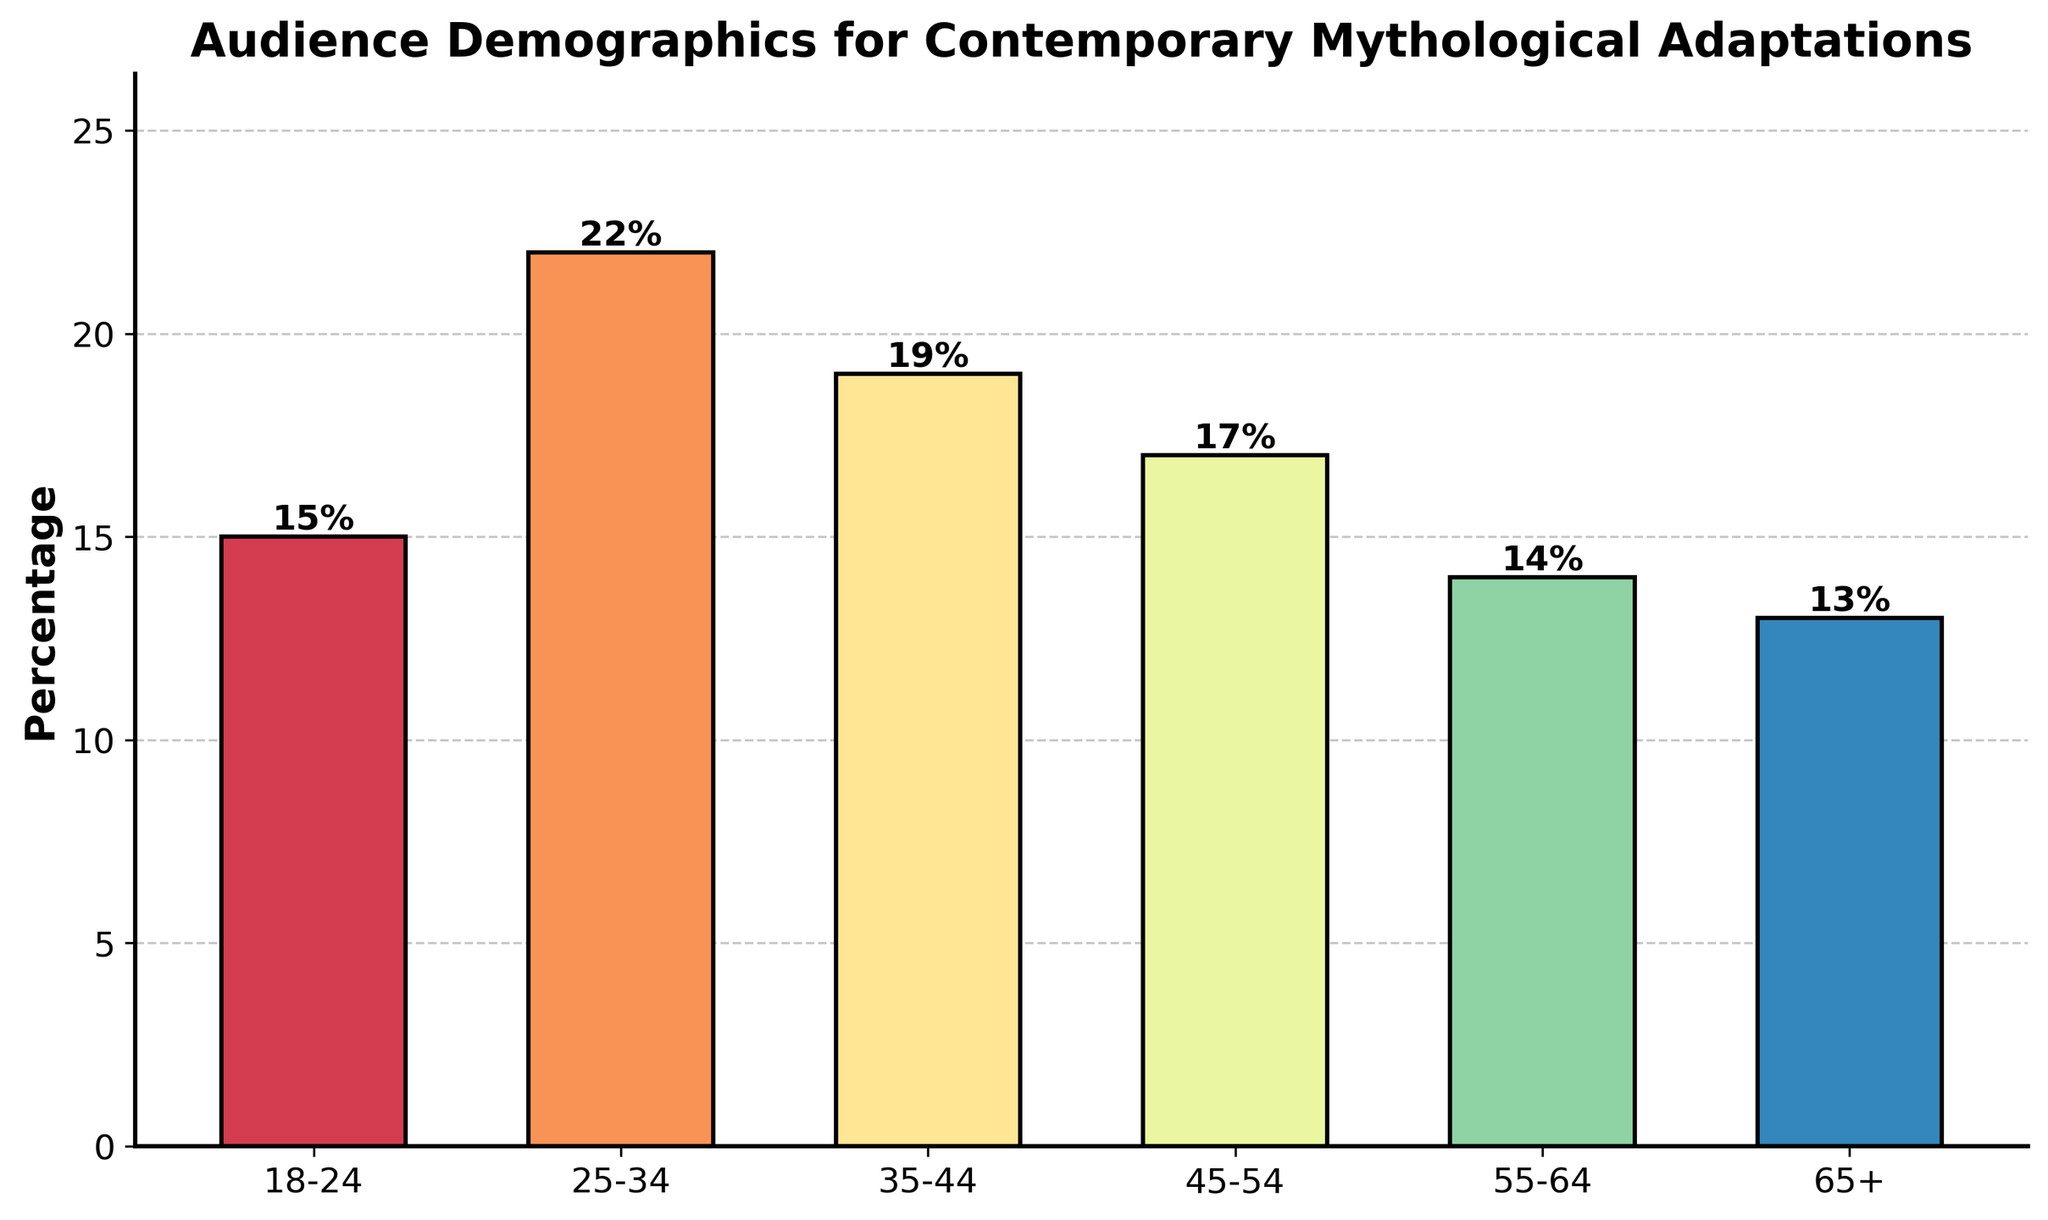What age group has the highest percentage of the audience? The tallest bar in the chart represents the age group with the highest percentage. The age group 25-34 has the highest bar at 22%.
Answer: 25-34 Which age group has the lowest percentage of the audience? The shortest bar in the chart represents the age group with the lowest percentage. The age group 65+ has the shortest bar at 13%.
Answer: 65+ What is the combined percentage of the audience for the 18-24 and 25-34 age groups? Add the percentages of the 18-24 and 25-34 age groups: 15% + 22% = 37%.
Answer: 37% Which age groups have a percentage of 17% or above? Identify the bars that reach or exceed the 17% mark. The age groups 25-34, 35-44, and 45-54 each have a percentage of 17% or higher.
Answer: 25-34, 35-44, 45-54 What is the difference in percentage between the 25-34 and 65+ age groups? Subtract the percentage of the 65+ age group from the percentage of the 25-34 age group: 22% - 13% = 9%.
Answer: 9% Which age group has a percentage closest to the overall average audience percentage? First, find the overall average percentage: (15% + 22% + 19% + 17% + 14% + 13%) / 6 = 16.67%. The age group closest to this average is 18-24 with 15%.
Answer: 18-24 Are there more audience members in the 45-54 age group or the 55-64 age group? Compare the heights of the bars for the 45-54 and 55-64 age groups. The 45-54 age group has 17% while the 55-64 age group has 14%.
Answer: 45-54 What is the total percentage for age groups under 35? Add the percentages of the 18-24 and 25-34 age groups: 15% + 22% = 37%.
Answer: 37% Which color represents the 55-64 age group and what can you say about its percentage? Identify the color used for the 55-64 age group. The corresponding bar is a shade of the color spectrum used, and its height indicates a percentage of 14%.
Answer: It's a shade in the spectrum used, 14% What is the median percentage value among all age groups? Arrange the percentages in order: 13%, 14%, 15%, 17%, 19%, 22%. The middle values are 15% and 17%, so the median is (15% + 17%) / 2 = 16%.
Answer: 16% 